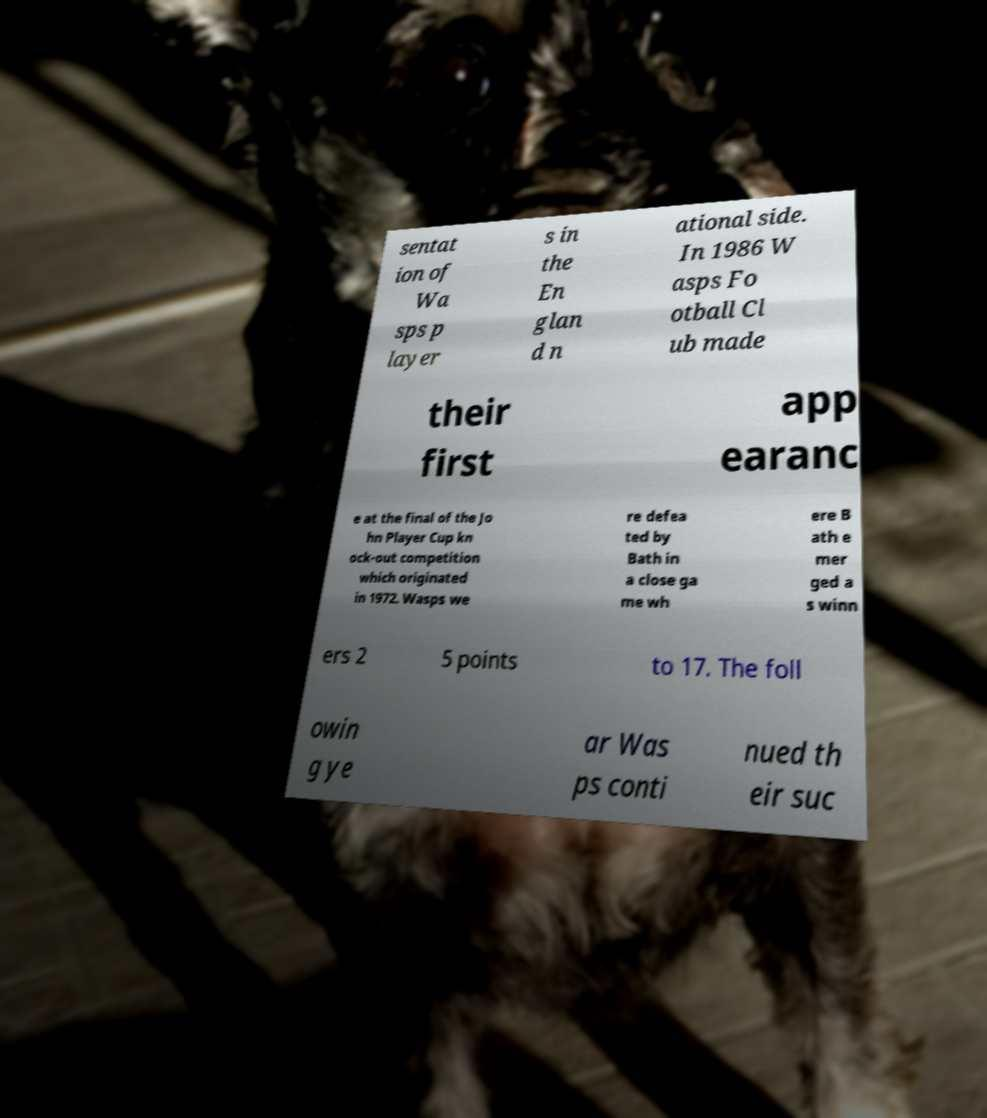Can you accurately transcribe the text from the provided image for me? sentat ion of Wa sps p layer s in the En glan d n ational side. In 1986 W asps Fo otball Cl ub made their first app earanc e at the final of the Jo hn Player Cup kn ock-out competition which originated in 1972. Wasps we re defea ted by Bath in a close ga me wh ere B ath e mer ged a s winn ers 2 5 points to 17. The foll owin g ye ar Was ps conti nued th eir suc 